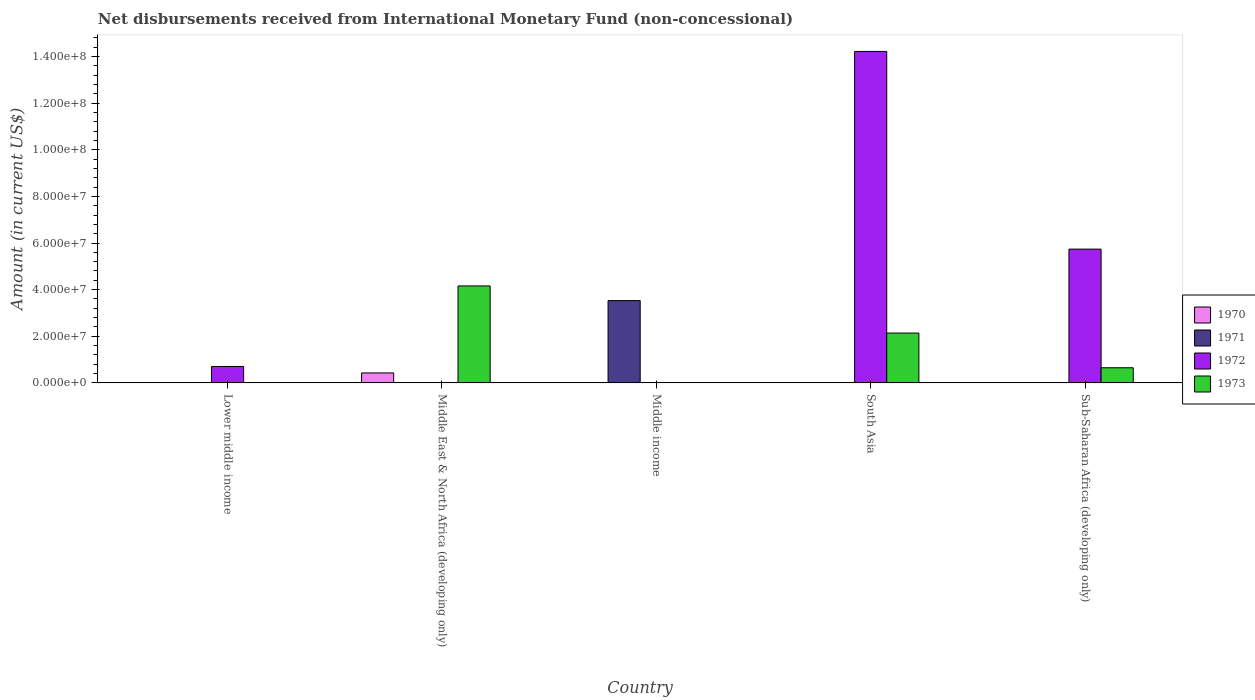How many different coloured bars are there?
Your response must be concise. 4. Are the number of bars per tick equal to the number of legend labels?
Your answer should be very brief. No. Are the number of bars on each tick of the X-axis equal?
Make the answer very short. No. How many bars are there on the 2nd tick from the left?
Offer a very short reply. 2. How many bars are there on the 5th tick from the right?
Ensure brevity in your answer.  1. In how many cases, is the number of bars for a given country not equal to the number of legend labels?
Your response must be concise. 5. What is the amount of disbursements received from International Monetary Fund in 1973 in Middle East & North Africa (developing only)?
Your response must be concise. 4.16e+07. Across all countries, what is the maximum amount of disbursements received from International Monetary Fund in 1973?
Keep it short and to the point. 4.16e+07. What is the total amount of disbursements received from International Monetary Fund in 1973 in the graph?
Your answer should be compact. 6.95e+07. What is the difference between the amount of disbursements received from International Monetary Fund in 1972 in South Asia and that in Sub-Saharan Africa (developing only)?
Offer a very short reply. 8.48e+07. What is the difference between the amount of disbursements received from International Monetary Fund in 1971 in South Asia and the amount of disbursements received from International Monetary Fund in 1970 in Lower middle income?
Keep it short and to the point. 0. What is the average amount of disbursements received from International Monetary Fund in 1971 per country?
Offer a terse response. 7.06e+06. What is the difference between the amount of disbursements received from International Monetary Fund of/in 1970 and amount of disbursements received from International Monetary Fund of/in 1973 in Middle East & North Africa (developing only)?
Make the answer very short. -3.73e+07. In how many countries, is the amount of disbursements received from International Monetary Fund in 1972 greater than 136000000 US$?
Offer a terse response. 1. What is the ratio of the amount of disbursements received from International Monetary Fund in 1972 in Lower middle income to that in South Asia?
Offer a terse response. 0.05. What is the difference between the highest and the second highest amount of disbursements received from International Monetary Fund in 1972?
Provide a succinct answer. 8.48e+07. What is the difference between the highest and the lowest amount of disbursements received from International Monetary Fund in 1972?
Keep it short and to the point. 1.42e+08. Is it the case that in every country, the sum of the amount of disbursements received from International Monetary Fund in 1973 and amount of disbursements received from International Monetary Fund in 1970 is greater than the sum of amount of disbursements received from International Monetary Fund in 1971 and amount of disbursements received from International Monetary Fund in 1972?
Provide a short and direct response. No. Is it the case that in every country, the sum of the amount of disbursements received from International Monetary Fund in 1972 and amount of disbursements received from International Monetary Fund in 1973 is greater than the amount of disbursements received from International Monetary Fund in 1971?
Your answer should be compact. No. How many bars are there?
Make the answer very short. 8. How many countries are there in the graph?
Keep it short and to the point. 5. Are the values on the major ticks of Y-axis written in scientific E-notation?
Provide a succinct answer. Yes. How many legend labels are there?
Offer a very short reply. 4. How are the legend labels stacked?
Provide a short and direct response. Vertical. What is the title of the graph?
Your answer should be very brief. Net disbursements received from International Monetary Fund (non-concessional). What is the label or title of the Y-axis?
Ensure brevity in your answer.  Amount (in current US$). What is the Amount (in current US$) of 1970 in Lower middle income?
Make the answer very short. 0. What is the Amount (in current US$) in 1971 in Lower middle income?
Offer a terse response. 0. What is the Amount (in current US$) of 1972 in Lower middle income?
Keep it short and to the point. 7.06e+06. What is the Amount (in current US$) of 1973 in Lower middle income?
Your response must be concise. 0. What is the Amount (in current US$) in 1970 in Middle East & North Africa (developing only)?
Provide a short and direct response. 4.30e+06. What is the Amount (in current US$) in 1973 in Middle East & North Africa (developing only)?
Offer a very short reply. 4.16e+07. What is the Amount (in current US$) of 1971 in Middle income?
Keep it short and to the point. 3.53e+07. What is the Amount (in current US$) in 1970 in South Asia?
Keep it short and to the point. 0. What is the Amount (in current US$) of 1972 in South Asia?
Provide a succinct answer. 1.42e+08. What is the Amount (in current US$) of 1973 in South Asia?
Ensure brevity in your answer.  2.14e+07. What is the Amount (in current US$) in 1972 in Sub-Saharan Africa (developing only)?
Your answer should be compact. 5.74e+07. What is the Amount (in current US$) in 1973 in Sub-Saharan Africa (developing only)?
Make the answer very short. 6.51e+06. Across all countries, what is the maximum Amount (in current US$) in 1970?
Keep it short and to the point. 4.30e+06. Across all countries, what is the maximum Amount (in current US$) of 1971?
Offer a terse response. 3.53e+07. Across all countries, what is the maximum Amount (in current US$) in 1972?
Your answer should be very brief. 1.42e+08. Across all countries, what is the maximum Amount (in current US$) in 1973?
Keep it short and to the point. 4.16e+07. Across all countries, what is the minimum Amount (in current US$) in 1970?
Make the answer very short. 0. Across all countries, what is the minimum Amount (in current US$) of 1972?
Ensure brevity in your answer.  0. Across all countries, what is the minimum Amount (in current US$) in 1973?
Give a very brief answer. 0. What is the total Amount (in current US$) in 1970 in the graph?
Keep it short and to the point. 4.30e+06. What is the total Amount (in current US$) in 1971 in the graph?
Give a very brief answer. 3.53e+07. What is the total Amount (in current US$) in 1972 in the graph?
Give a very brief answer. 2.07e+08. What is the total Amount (in current US$) in 1973 in the graph?
Ensure brevity in your answer.  6.95e+07. What is the difference between the Amount (in current US$) of 1972 in Lower middle income and that in South Asia?
Provide a succinct answer. -1.35e+08. What is the difference between the Amount (in current US$) of 1972 in Lower middle income and that in Sub-Saharan Africa (developing only)?
Ensure brevity in your answer.  -5.03e+07. What is the difference between the Amount (in current US$) in 1973 in Middle East & North Africa (developing only) and that in South Asia?
Your response must be concise. 2.02e+07. What is the difference between the Amount (in current US$) in 1973 in Middle East & North Africa (developing only) and that in Sub-Saharan Africa (developing only)?
Ensure brevity in your answer.  3.51e+07. What is the difference between the Amount (in current US$) in 1972 in South Asia and that in Sub-Saharan Africa (developing only)?
Ensure brevity in your answer.  8.48e+07. What is the difference between the Amount (in current US$) of 1973 in South Asia and that in Sub-Saharan Africa (developing only)?
Provide a short and direct response. 1.49e+07. What is the difference between the Amount (in current US$) of 1972 in Lower middle income and the Amount (in current US$) of 1973 in Middle East & North Africa (developing only)?
Your response must be concise. -3.45e+07. What is the difference between the Amount (in current US$) in 1972 in Lower middle income and the Amount (in current US$) in 1973 in South Asia?
Provide a succinct answer. -1.43e+07. What is the difference between the Amount (in current US$) in 1972 in Lower middle income and the Amount (in current US$) in 1973 in Sub-Saharan Africa (developing only)?
Make the answer very short. 5.46e+05. What is the difference between the Amount (in current US$) in 1970 in Middle East & North Africa (developing only) and the Amount (in current US$) in 1971 in Middle income?
Your answer should be very brief. -3.10e+07. What is the difference between the Amount (in current US$) of 1970 in Middle East & North Africa (developing only) and the Amount (in current US$) of 1972 in South Asia?
Make the answer very short. -1.38e+08. What is the difference between the Amount (in current US$) of 1970 in Middle East & North Africa (developing only) and the Amount (in current US$) of 1973 in South Asia?
Make the answer very short. -1.71e+07. What is the difference between the Amount (in current US$) in 1970 in Middle East & North Africa (developing only) and the Amount (in current US$) in 1972 in Sub-Saharan Africa (developing only)?
Keep it short and to the point. -5.31e+07. What is the difference between the Amount (in current US$) of 1970 in Middle East & North Africa (developing only) and the Amount (in current US$) of 1973 in Sub-Saharan Africa (developing only)?
Offer a terse response. -2.21e+06. What is the difference between the Amount (in current US$) in 1971 in Middle income and the Amount (in current US$) in 1972 in South Asia?
Your response must be concise. -1.07e+08. What is the difference between the Amount (in current US$) in 1971 in Middle income and the Amount (in current US$) in 1973 in South Asia?
Make the answer very short. 1.39e+07. What is the difference between the Amount (in current US$) in 1971 in Middle income and the Amount (in current US$) in 1972 in Sub-Saharan Africa (developing only)?
Ensure brevity in your answer.  -2.21e+07. What is the difference between the Amount (in current US$) of 1971 in Middle income and the Amount (in current US$) of 1973 in Sub-Saharan Africa (developing only)?
Keep it short and to the point. 2.88e+07. What is the difference between the Amount (in current US$) of 1972 in South Asia and the Amount (in current US$) of 1973 in Sub-Saharan Africa (developing only)?
Your answer should be very brief. 1.36e+08. What is the average Amount (in current US$) of 1970 per country?
Offer a very short reply. 8.60e+05. What is the average Amount (in current US$) of 1971 per country?
Your answer should be very brief. 7.06e+06. What is the average Amount (in current US$) in 1972 per country?
Your answer should be compact. 4.13e+07. What is the average Amount (in current US$) in 1973 per country?
Offer a terse response. 1.39e+07. What is the difference between the Amount (in current US$) of 1970 and Amount (in current US$) of 1973 in Middle East & North Africa (developing only)?
Your answer should be very brief. -3.73e+07. What is the difference between the Amount (in current US$) of 1972 and Amount (in current US$) of 1973 in South Asia?
Your answer should be very brief. 1.21e+08. What is the difference between the Amount (in current US$) in 1972 and Amount (in current US$) in 1973 in Sub-Saharan Africa (developing only)?
Ensure brevity in your answer.  5.09e+07. What is the ratio of the Amount (in current US$) in 1972 in Lower middle income to that in South Asia?
Offer a very short reply. 0.05. What is the ratio of the Amount (in current US$) of 1972 in Lower middle income to that in Sub-Saharan Africa (developing only)?
Your answer should be compact. 0.12. What is the ratio of the Amount (in current US$) in 1973 in Middle East & North Africa (developing only) to that in South Asia?
Provide a succinct answer. 1.94. What is the ratio of the Amount (in current US$) in 1973 in Middle East & North Africa (developing only) to that in Sub-Saharan Africa (developing only)?
Offer a very short reply. 6.39. What is the ratio of the Amount (in current US$) of 1972 in South Asia to that in Sub-Saharan Africa (developing only)?
Offer a very short reply. 2.48. What is the ratio of the Amount (in current US$) of 1973 in South Asia to that in Sub-Saharan Africa (developing only)?
Ensure brevity in your answer.  3.29. What is the difference between the highest and the second highest Amount (in current US$) in 1972?
Provide a short and direct response. 8.48e+07. What is the difference between the highest and the second highest Amount (in current US$) of 1973?
Ensure brevity in your answer.  2.02e+07. What is the difference between the highest and the lowest Amount (in current US$) of 1970?
Provide a short and direct response. 4.30e+06. What is the difference between the highest and the lowest Amount (in current US$) of 1971?
Give a very brief answer. 3.53e+07. What is the difference between the highest and the lowest Amount (in current US$) of 1972?
Provide a short and direct response. 1.42e+08. What is the difference between the highest and the lowest Amount (in current US$) in 1973?
Your answer should be very brief. 4.16e+07. 